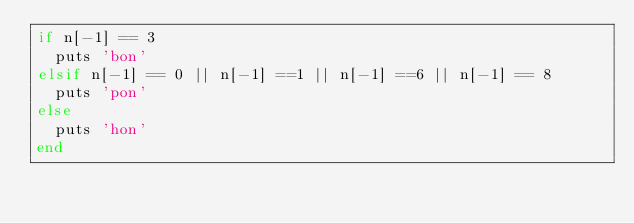<code> <loc_0><loc_0><loc_500><loc_500><_Ruby_>if n[-1] == 3
  puts 'bon'
elsif n[-1] == 0 || n[-1] ==1 || n[-1] ==6 || n[-1] == 8
  puts 'pon'
else
  puts 'hon'
end</code> 